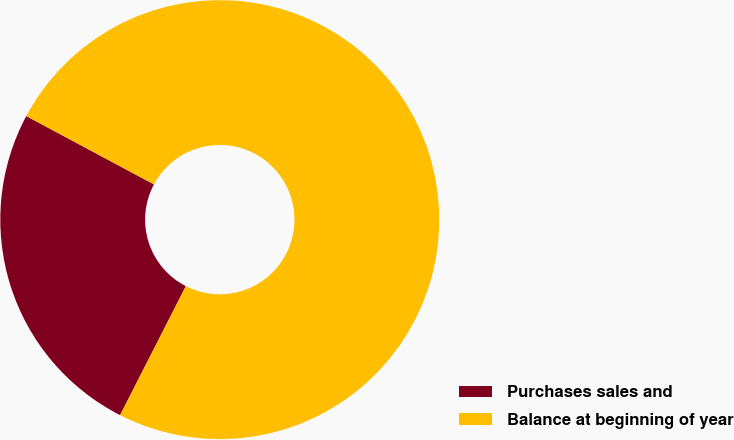<chart> <loc_0><loc_0><loc_500><loc_500><pie_chart><fcel>Purchases sales and<fcel>Balance at beginning of year<nl><fcel>25.32%<fcel>74.68%<nl></chart> 